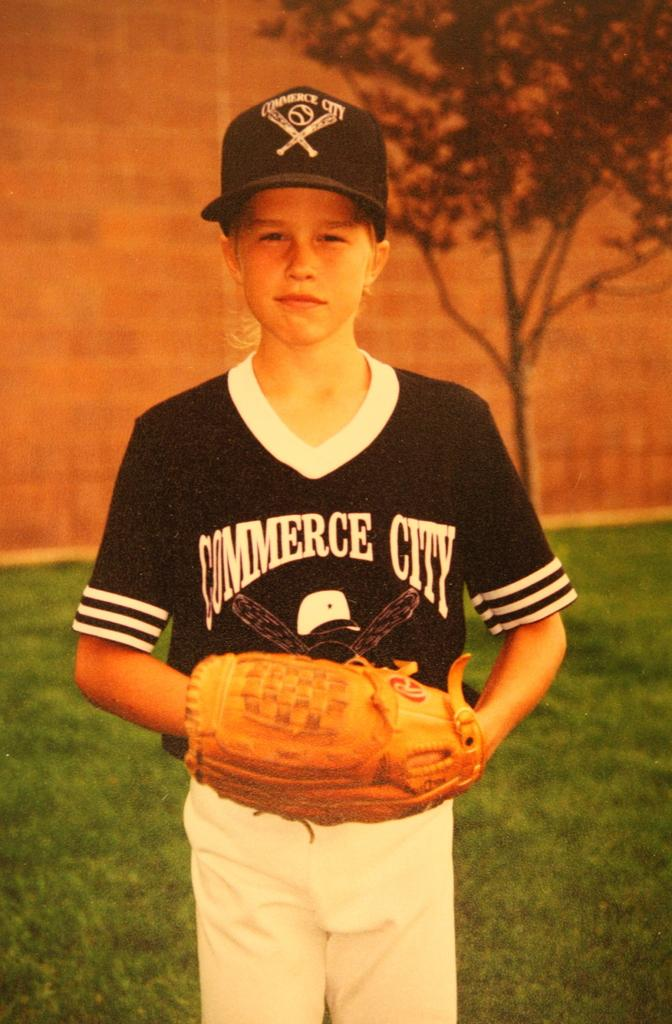<image>
Summarize the visual content of the image. Little League baseball player wearing a shirt that says Commerce City. 